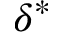Convert formula to latex. <formula><loc_0><loc_0><loc_500><loc_500>\delta ^ { * }</formula> 